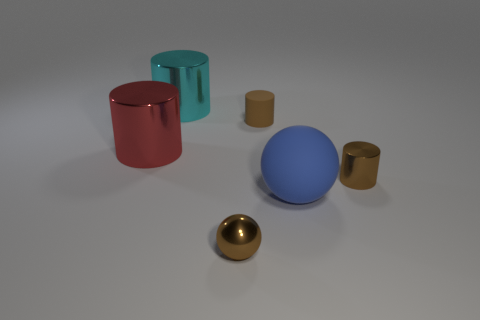How many big red objects have the same shape as the cyan thing?
Your response must be concise. 1. Is the material of the cylinder that is in front of the large red object the same as the small cylinder on the left side of the blue thing?
Provide a succinct answer. No. How big is the brown cylinder behind the metallic cylinder that is on the right side of the cyan metallic object?
Offer a very short reply. Small. Is there anything else that is the same size as the brown ball?
Provide a short and direct response. Yes. There is a red thing that is the same shape as the cyan thing; what is its material?
Make the answer very short. Metal. There is a cyan shiny thing on the right side of the big red cylinder; does it have the same shape as the matte object that is to the left of the rubber sphere?
Make the answer very short. Yes. Are there more small cylinders than tiny blue rubber things?
Provide a short and direct response. Yes. What is the size of the red object?
Offer a very short reply. Large. How many other things are the same color as the tiny rubber cylinder?
Your answer should be compact. 2. Does the brown cylinder in front of the large red metallic object have the same material as the large ball?
Ensure brevity in your answer.  No. 